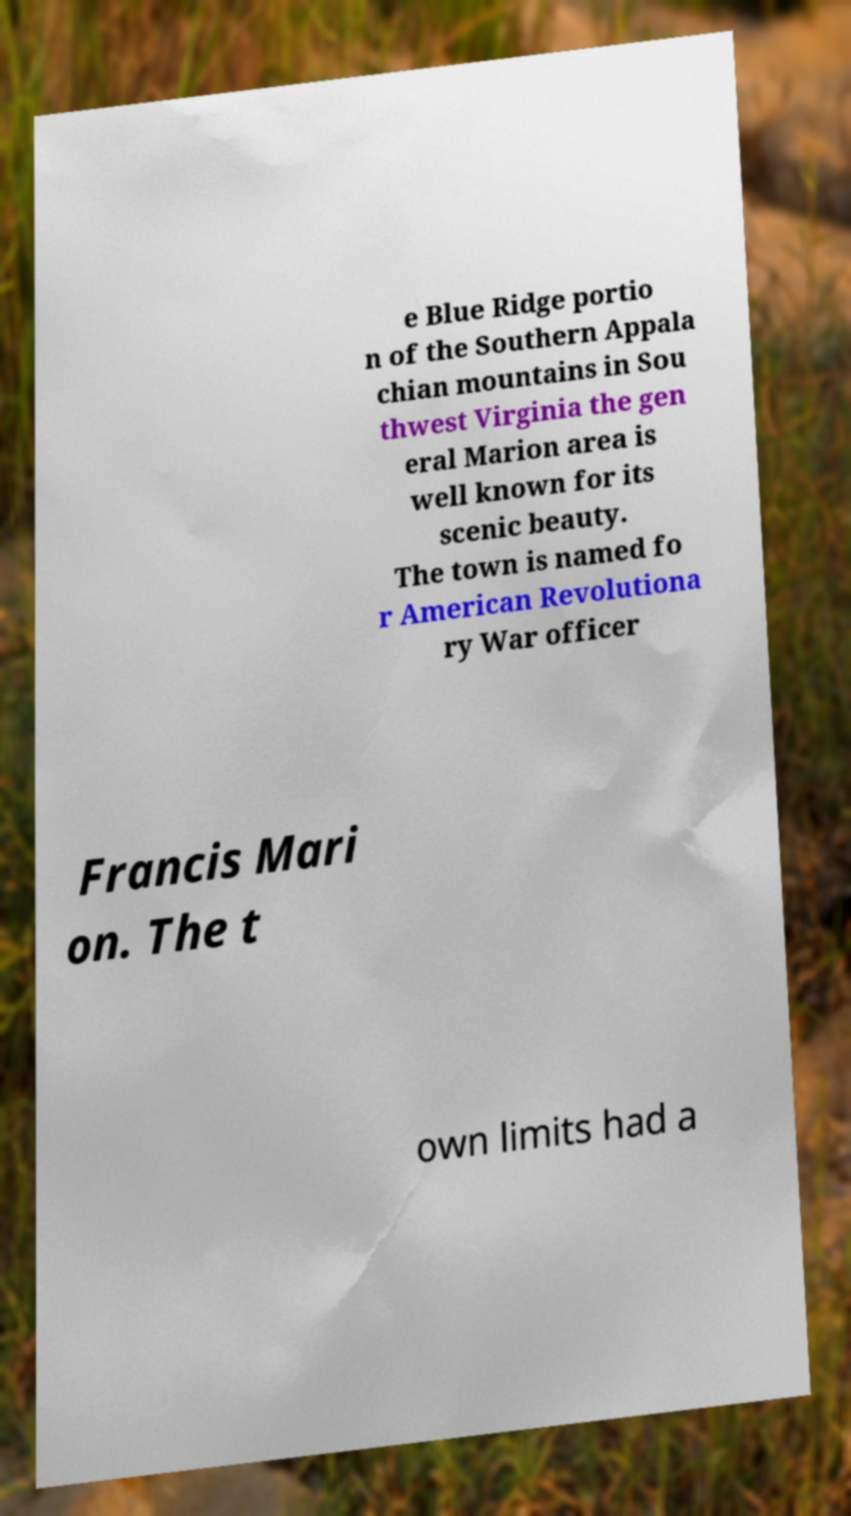Could you assist in decoding the text presented in this image and type it out clearly? e Blue Ridge portio n of the Southern Appala chian mountains in Sou thwest Virginia the gen eral Marion area is well known for its scenic beauty. The town is named fo r American Revolutiona ry War officer Francis Mari on. The t own limits had a 